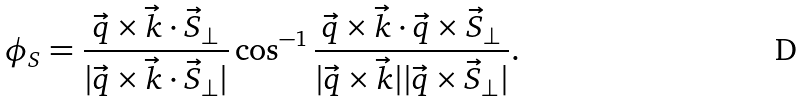<formula> <loc_0><loc_0><loc_500><loc_500>\phi _ { S } = \frac { \vec { q } \times \vec { k } \cdot \vec { S } _ { \perp } } { | \vec { q } \times \vec { k } \cdot \vec { S } _ { \perp } | } \cos ^ { - 1 } { \frac { \vec { q } \times \vec { k } \cdot \vec { q } \times \vec { S } _ { \perp } } { | \vec { q } \times \vec { k } | | \vec { q } \times \vec { S } _ { \perp } | } } .</formula> 